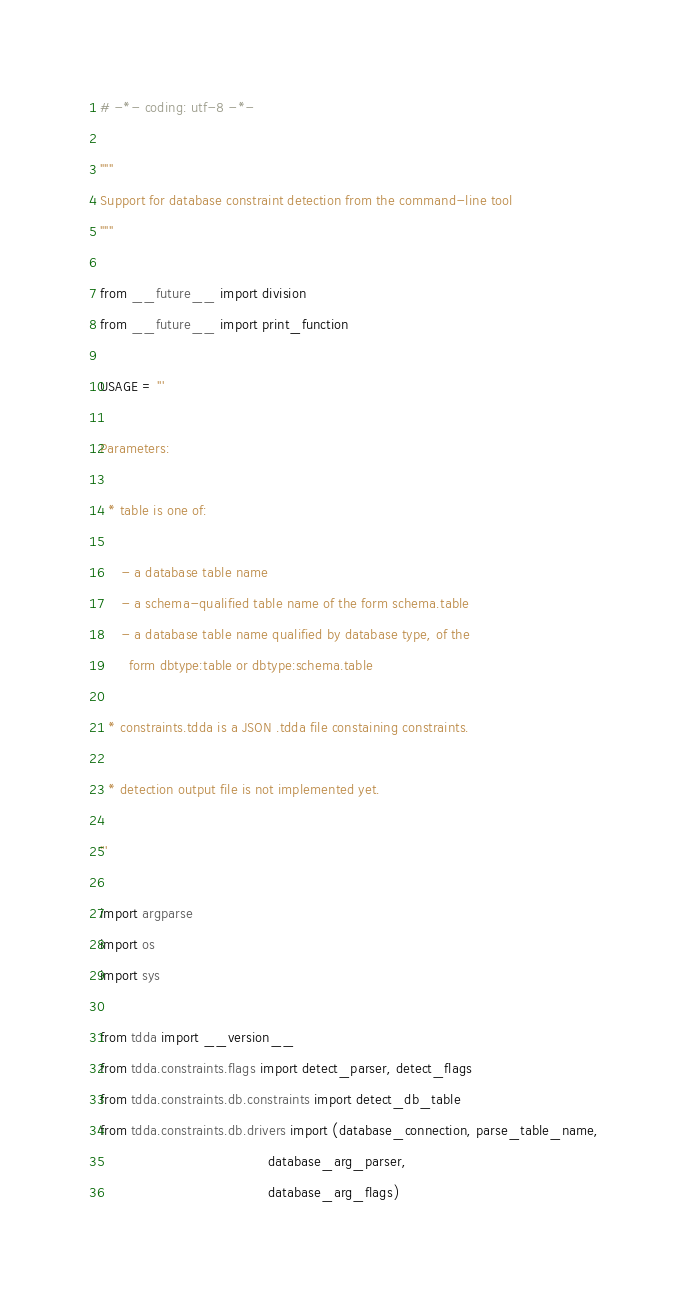<code> <loc_0><loc_0><loc_500><loc_500><_Python_># -*- coding: utf-8 -*-

"""
Support for database constraint detection from the command-line tool
"""

from __future__ import division
from __future__ import print_function

USAGE = '''

Parameters:

  * table is one of:

     - a database table name
     - a schema-qualified table name of the form schema.table
     - a database table name qualified by database type, of the
       form dbtype:table or dbtype:schema.table

  * constraints.tdda is a JSON .tdda file constaining constraints.

  * detection output file is not implemented yet.

'''

import argparse
import os
import sys

from tdda import __version__
from tdda.constraints.flags import detect_parser, detect_flags
from tdda.constraints.db.constraints import detect_db_table
from tdda.constraints.db.drivers import (database_connection, parse_table_name,
                                         database_arg_parser,
                                         database_arg_flags)

</code> 